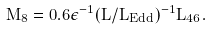<formula> <loc_0><loc_0><loc_500><loc_500>M _ { 8 } = 0 . 6 \epsilon ^ { - 1 } ( L / L _ { E d d } ) ^ { - 1 } L _ { 4 6 } .</formula> 